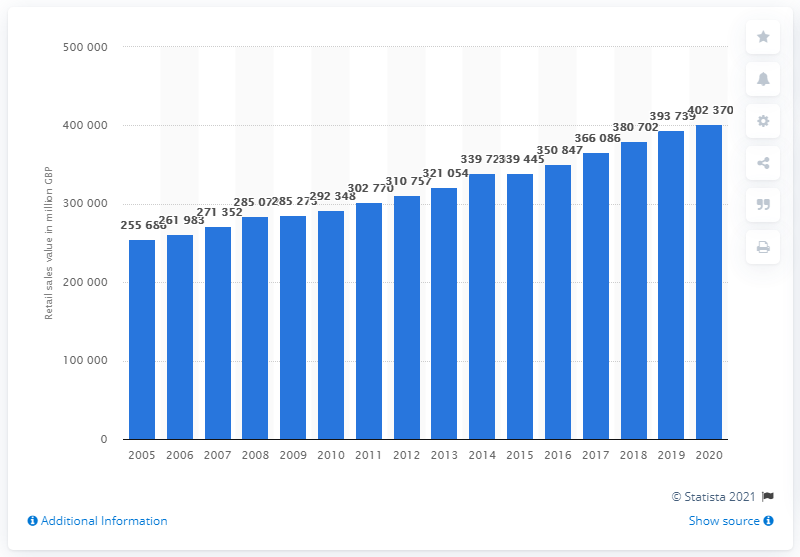Point out several critical features in this image. In 2020, the value of retail sales in Britain was approximately 402,370 million pounds. 